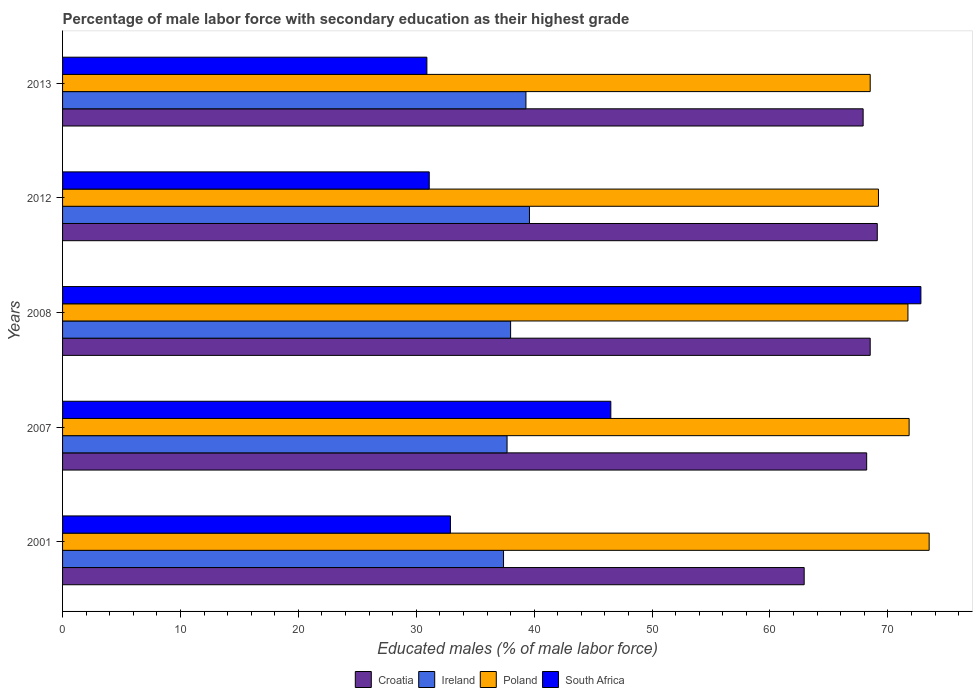How many bars are there on the 3rd tick from the top?
Offer a very short reply. 4. What is the label of the 5th group of bars from the top?
Ensure brevity in your answer.  2001. In how many cases, is the number of bars for a given year not equal to the number of legend labels?
Your answer should be very brief. 0. What is the percentage of male labor force with secondary education in Ireland in 2013?
Give a very brief answer. 39.3. Across all years, what is the maximum percentage of male labor force with secondary education in Poland?
Give a very brief answer. 73.5. Across all years, what is the minimum percentage of male labor force with secondary education in South Africa?
Make the answer very short. 30.9. In which year was the percentage of male labor force with secondary education in South Africa maximum?
Your response must be concise. 2008. In which year was the percentage of male labor force with secondary education in Poland minimum?
Ensure brevity in your answer.  2013. What is the total percentage of male labor force with secondary education in Ireland in the graph?
Ensure brevity in your answer.  192. What is the difference between the percentage of male labor force with secondary education in Croatia in 2007 and that in 2008?
Offer a terse response. -0.3. What is the difference between the percentage of male labor force with secondary education in Poland in 2008 and the percentage of male labor force with secondary education in South Africa in 2001?
Offer a very short reply. 38.8. What is the average percentage of male labor force with secondary education in South Africa per year?
Make the answer very short. 42.84. In the year 2013, what is the difference between the percentage of male labor force with secondary education in Poland and percentage of male labor force with secondary education in Croatia?
Offer a terse response. 0.6. In how many years, is the percentage of male labor force with secondary education in Croatia greater than 42 %?
Give a very brief answer. 5. What is the ratio of the percentage of male labor force with secondary education in Poland in 2001 to that in 2012?
Offer a terse response. 1.06. Is the difference between the percentage of male labor force with secondary education in Poland in 2001 and 2013 greater than the difference between the percentage of male labor force with secondary education in Croatia in 2001 and 2013?
Your response must be concise. Yes. What is the difference between the highest and the second highest percentage of male labor force with secondary education in South Africa?
Your answer should be very brief. 26.3. What is the difference between the highest and the lowest percentage of male labor force with secondary education in Ireland?
Make the answer very short. 2.2. In how many years, is the percentage of male labor force with secondary education in Croatia greater than the average percentage of male labor force with secondary education in Croatia taken over all years?
Your answer should be very brief. 4. Is the sum of the percentage of male labor force with secondary education in South Africa in 2012 and 2013 greater than the maximum percentage of male labor force with secondary education in Croatia across all years?
Your response must be concise. No. What does the 3rd bar from the top in 2001 represents?
Your answer should be very brief. Ireland. What does the 2nd bar from the bottom in 2012 represents?
Ensure brevity in your answer.  Ireland. How many bars are there?
Offer a very short reply. 20. Are all the bars in the graph horizontal?
Ensure brevity in your answer.  Yes. Are the values on the major ticks of X-axis written in scientific E-notation?
Provide a short and direct response. No. Where does the legend appear in the graph?
Your answer should be compact. Bottom center. What is the title of the graph?
Provide a succinct answer. Percentage of male labor force with secondary education as their highest grade. What is the label or title of the X-axis?
Your answer should be compact. Educated males (% of male labor force). What is the Educated males (% of male labor force) of Croatia in 2001?
Give a very brief answer. 62.9. What is the Educated males (% of male labor force) of Ireland in 2001?
Your response must be concise. 37.4. What is the Educated males (% of male labor force) of Poland in 2001?
Give a very brief answer. 73.5. What is the Educated males (% of male labor force) in South Africa in 2001?
Ensure brevity in your answer.  32.9. What is the Educated males (% of male labor force) in Croatia in 2007?
Keep it short and to the point. 68.2. What is the Educated males (% of male labor force) in Ireland in 2007?
Keep it short and to the point. 37.7. What is the Educated males (% of male labor force) of Poland in 2007?
Provide a succinct answer. 71.8. What is the Educated males (% of male labor force) in South Africa in 2007?
Give a very brief answer. 46.5. What is the Educated males (% of male labor force) of Croatia in 2008?
Offer a terse response. 68.5. What is the Educated males (% of male labor force) of Ireland in 2008?
Your response must be concise. 38. What is the Educated males (% of male labor force) of Poland in 2008?
Offer a terse response. 71.7. What is the Educated males (% of male labor force) of South Africa in 2008?
Ensure brevity in your answer.  72.8. What is the Educated males (% of male labor force) in Croatia in 2012?
Make the answer very short. 69.1. What is the Educated males (% of male labor force) of Ireland in 2012?
Provide a succinct answer. 39.6. What is the Educated males (% of male labor force) in Poland in 2012?
Your answer should be very brief. 69.2. What is the Educated males (% of male labor force) in South Africa in 2012?
Make the answer very short. 31.1. What is the Educated males (% of male labor force) of Croatia in 2013?
Provide a succinct answer. 67.9. What is the Educated males (% of male labor force) in Ireland in 2013?
Your answer should be very brief. 39.3. What is the Educated males (% of male labor force) in Poland in 2013?
Give a very brief answer. 68.5. What is the Educated males (% of male labor force) in South Africa in 2013?
Give a very brief answer. 30.9. Across all years, what is the maximum Educated males (% of male labor force) of Croatia?
Give a very brief answer. 69.1. Across all years, what is the maximum Educated males (% of male labor force) of Ireland?
Give a very brief answer. 39.6. Across all years, what is the maximum Educated males (% of male labor force) in Poland?
Provide a succinct answer. 73.5. Across all years, what is the maximum Educated males (% of male labor force) in South Africa?
Keep it short and to the point. 72.8. Across all years, what is the minimum Educated males (% of male labor force) of Croatia?
Provide a succinct answer. 62.9. Across all years, what is the minimum Educated males (% of male labor force) of Ireland?
Your answer should be very brief. 37.4. Across all years, what is the minimum Educated males (% of male labor force) in Poland?
Offer a very short reply. 68.5. Across all years, what is the minimum Educated males (% of male labor force) in South Africa?
Ensure brevity in your answer.  30.9. What is the total Educated males (% of male labor force) in Croatia in the graph?
Give a very brief answer. 336.6. What is the total Educated males (% of male labor force) of Ireland in the graph?
Your answer should be compact. 192. What is the total Educated males (% of male labor force) in Poland in the graph?
Your response must be concise. 354.7. What is the total Educated males (% of male labor force) in South Africa in the graph?
Give a very brief answer. 214.2. What is the difference between the Educated males (% of male labor force) of Ireland in 2001 and that in 2007?
Give a very brief answer. -0.3. What is the difference between the Educated males (% of male labor force) in Poland in 2001 and that in 2008?
Ensure brevity in your answer.  1.8. What is the difference between the Educated males (% of male labor force) of South Africa in 2001 and that in 2008?
Keep it short and to the point. -39.9. What is the difference between the Educated males (% of male labor force) of Poland in 2001 and that in 2012?
Offer a very short reply. 4.3. What is the difference between the Educated males (% of male labor force) of South Africa in 2001 and that in 2012?
Ensure brevity in your answer.  1.8. What is the difference between the Educated males (% of male labor force) in Croatia in 2001 and that in 2013?
Ensure brevity in your answer.  -5. What is the difference between the Educated males (% of male labor force) of Ireland in 2001 and that in 2013?
Offer a terse response. -1.9. What is the difference between the Educated males (% of male labor force) in Poland in 2001 and that in 2013?
Offer a terse response. 5. What is the difference between the Educated males (% of male labor force) in South Africa in 2001 and that in 2013?
Give a very brief answer. 2. What is the difference between the Educated males (% of male labor force) of Ireland in 2007 and that in 2008?
Offer a very short reply. -0.3. What is the difference between the Educated males (% of male labor force) in Poland in 2007 and that in 2008?
Give a very brief answer. 0.1. What is the difference between the Educated males (% of male labor force) of South Africa in 2007 and that in 2008?
Your response must be concise. -26.3. What is the difference between the Educated males (% of male labor force) of Croatia in 2007 and that in 2012?
Make the answer very short. -0.9. What is the difference between the Educated males (% of male labor force) of Poland in 2007 and that in 2012?
Ensure brevity in your answer.  2.6. What is the difference between the Educated males (% of male labor force) of South Africa in 2007 and that in 2012?
Offer a very short reply. 15.4. What is the difference between the Educated males (% of male labor force) of Croatia in 2007 and that in 2013?
Provide a succinct answer. 0.3. What is the difference between the Educated males (% of male labor force) of Poland in 2007 and that in 2013?
Your answer should be compact. 3.3. What is the difference between the Educated males (% of male labor force) of Croatia in 2008 and that in 2012?
Ensure brevity in your answer.  -0.6. What is the difference between the Educated males (% of male labor force) in Poland in 2008 and that in 2012?
Ensure brevity in your answer.  2.5. What is the difference between the Educated males (% of male labor force) of South Africa in 2008 and that in 2012?
Offer a very short reply. 41.7. What is the difference between the Educated males (% of male labor force) of South Africa in 2008 and that in 2013?
Your response must be concise. 41.9. What is the difference between the Educated males (% of male labor force) of Croatia in 2001 and the Educated males (% of male labor force) of Ireland in 2007?
Your answer should be very brief. 25.2. What is the difference between the Educated males (% of male labor force) in Croatia in 2001 and the Educated males (% of male labor force) in Poland in 2007?
Your response must be concise. -8.9. What is the difference between the Educated males (% of male labor force) of Ireland in 2001 and the Educated males (% of male labor force) of Poland in 2007?
Ensure brevity in your answer.  -34.4. What is the difference between the Educated males (% of male labor force) in Ireland in 2001 and the Educated males (% of male labor force) in South Africa in 2007?
Keep it short and to the point. -9.1. What is the difference between the Educated males (% of male labor force) in Croatia in 2001 and the Educated males (% of male labor force) in Ireland in 2008?
Your answer should be very brief. 24.9. What is the difference between the Educated males (% of male labor force) of Croatia in 2001 and the Educated males (% of male labor force) of Poland in 2008?
Provide a succinct answer. -8.8. What is the difference between the Educated males (% of male labor force) in Ireland in 2001 and the Educated males (% of male labor force) in Poland in 2008?
Offer a very short reply. -34.3. What is the difference between the Educated males (% of male labor force) in Ireland in 2001 and the Educated males (% of male labor force) in South Africa in 2008?
Offer a very short reply. -35.4. What is the difference between the Educated males (% of male labor force) of Poland in 2001 and the Educated males (% of male labor force) of South Africa in 2008?
Make the answer very short. 0.7. What is the difference between the Educated males (% of male labor force) of Croatia in 2001 and the Educated males (% of male labor force) of Ireland in 2012?
Offer a very short reply. 23.3. What is the difference between the Educated males (% of male labor force) of Croatia in 2001 and the Educated males (% of male labor force) of South Africa in 2012?
Provide a succinct answer. 31.8. What is the difference between the Educated males (% of male labor force) of Ireland in 2001 and the Educated males (% of male labor force) of Poland in 2012?
Ensure brevity in your answer.  -31.8. What is the difference between the Educated males (% of male labor force) of Ireland in 2001 and the Educated males (% of male labor force) of South Africa in 2012?
Provide a succinct answer. 6.3. What is the difference between the Educated males (% of male labor force) of Poland in 2001 and the Educated males (% of male labor force) of South Africa in 2012?
Offer a terse response. 42.4. What is the difference between the Educated males (% of male labor force) in Croatia in 2001 and the Educated males (% of male labor force) in Ireland in 2013?
Your answer should be compact. 23.6. What is the difference between the Educated males (% of male labor force) of Ireland in 2001 and the Educated males (% of male labor force) of Poland in 2013?
Your response must be concise. -31.1. What is the difference between the Educated males (% of male labor force) in Ireland in 2001 and the Educated males (% of male labor force) in South Africa in 2013?
Keep it short and to the point. 6.5. What is the difference between the Educated males (% of male labor force) in Poland in 2001 and the Educated males (% of male labor force) in South Africa in 2013?
Your answer should be compact. 42.6. What is the difference between the Educated males (% of male labor force) in Croatia in 2007 and the Educated males (% of male labor force) in Ireland in 2008?
Your answer should be very brief. 30.2. What is the difference between the Educated males (% of male labor force) in Croatia in 2007 and the Educated males (% of male labor force) in Poland in 2008?
Offer a very short reply. -3.5. What is the difference between the Educated males (% of male labor force) in Ireland in 2007 and the Educated males (% of male labor force) in Poland in 2008?
Ensure brevity in your answer.  -34. What is the difference between the Educated males (% of male labor force) in Ireland in 2007 and the Educated males (% of male labor force) in South Africa in 2008?
Make the answer very short. -35.1. What is the difference between the Educated males (% of male labor force) in Poland in 2007 and the Educated males (% of male labor force) in South Africa in 2008?
Keep it short and to the point. -1. What is the difference between the Educated males (% of male labor force) in Croatia in 2007 and the Educated males (% of male labor force) in Ireland in 2012?
Your answer should be very brief. 28.6. What is the difference between the Educated males (% of male labor force) in Croatia in 2007 and the Educated males (% of male labor force) in Poland in 2012?
Make the answer very short. -1. What is the difference between the Educated males (% of male labor force) of Croatia in 2007 and the Educated males (% of male labor force) of South Africa in 2012?
Your answer should be very brief. 37.1. What is the difference between the Educated males (% of male labor force) of Ireland in 2007 and the Educated males (% of male labor force) of Poland in 2012?
Provide a short and direct response. -31.5. What is the difference between the Educated males (% of male labor force) of Ireland in 2007 and the Educated males (% of male labor force) of South Africa in 2012?
Your answer should be very brief. 6.6. What is the difference between the Educated males (% of male labor force) in Poland in 2007 and the Educated males (% of male labor force) in South Africa in 2012?
Your answer should be compact. 40.7. What is the difference between the Educated males (% of male labor force) of Croatia in 2007 and the Educated males (% of male labor force) of Ireland in 2013?
Offer a terse response. 28.9. What is the difference between the Educated males (% of male labor force) of Croatia in 2007 and the Educated males (% of male labor force) of South Africa in 2013?
Give a very brief answer. 37.3. What is the difference between the Educated males (% of male labor force) of Ireland in 2007 and the Educated males (% of male labor force) of Poland in 2013?
Make the answer very short. -30.8. What is the difference between the Educated males (% of male labor force) in Poland in 2007 and the Educated males (% of male labor force) in South Africa in 2013?
Offer a terse response. 40.9. What is the difference between the Educated males (% of male labor force) of Croatia in 2008 and the Educated males (% of male labor force) of Ireland in 2012?
Your answer should be very brief. 28.9. What is the difference between the Educated males (% of male labor force) of Croatia in 2008 and the Educated males (% of male labor force) of Poland in 2012?
Make the answer very short. -0.7. What is the difference between the Educated males (% of male labor force) of Croatia in 2008 and the Educated males (% of male labor force) of South Africa in 2012?
Make the answer very short. 37.4. What is the difference between the Educated males (% of male labor force) in Ireland in 2008 and the Educated males (% of male labor force) in Poland in 2012?
Provide a succinct answer. -31.2. What is the difference between the Educated males (% of male labor force) in Poland in 2008 and the Educated males (% of male labor force) in South Africa in 2012?
Make the answer very short. 40.6. What is the difference between the Educated males (% of male labor force) of Croatia in 2008 and the Educated males (% of male labor force) of Ireland in 2013?
Your answer should be compact. 29.2. What is the difference between the Educated males (% of male labor force) in Croatia in 2008 and the Educated males (% of male labor force) in South Africa in 2013?
Offer a very short reply. 37.6. What is the difference between the Educated males (% of male labor force) in Ireland in 2008 and the Educated males (% of male labor force) in Poland in 2013?
Provide a succinct answer. -30.5. What is the difference between the Educated males (% of male labor force) of Ireland in 2008 and the Educated males (% of male labor force) of South Africa in 2013?
Ensure brevity in your answer.  7.1. What is the difference between the Educated males (% of male labor force) of Poland in 2008 and the Educated males (% of male labor force) of South Africa in 2013?
Your answer should be very brief. 40.8. What is the difference between the Educated males (% of male labor force) in Croatia in 2012 and the Educated males (% of male labor force) in Ireland in 2013?
Give a very brief answer. 29.8. What is the difference between the Educated males (% of male labor force) of Croatia in 2012 and the Educated males (% of male labor force) of Poland in 2013?
Provide a succinct answer. 0.6. What is the difference between the Educated males (% of male labor force) of Croatia in 2012 and the Educated males (% of male labor force) of South Africa in 2013?
Make the answer very short. 38.2. What is the difference between the Educated males (% of male labor force) of Ireland in 2012 and the Educated males (% of male labor force) of Poland in 2013?
Provide a succinct answer. -28.9. What is the difference between the Educated males (% of male labor force) in Poland in 2012 and the Educated males (% of male labor force) in South Africa in 2013?
Provide a succinct answer. 38.3. What is the average Educated males (% of male labor force) in Croatia per year?
Provide a short and direct response. 67.32. What is the average Educated males (% of male labor force) of Ireland per year?
Ensure brevity in your answer.  38.4. What is the average Educated males (% of male labor force) in Poland per year?
Keep it short and to the point. 70.94. What is the average Educated males (% of male labor force) in South Africa per year?
Give a very brief answer. 42.84. In the year 2001, what is the difference between the Educated males (% of male labor force) of Ireland and Educated males (% of male labor force) of Poland?
Give a very brief answer. -36.1. In the year 2001, what is the difference between the Educated males (% of male labor force) of Poland and Educated males (% of male labor force) of South Africa?
Ensure brevity in your answer.  40.6. In the year 2007, what is the difference between the Educated males (% of male labor force) of Croatia and Educated males (% of male labor force) of Ireland?
Offer a terse response. 30.5. In the year 2007, what is the difference between the Educated males (% of male labor force) in Croatia and Educated males (% of male labor force) in Poland?
Your answer should be compact. -3.6. In the year 2007, what is the difference between the Educated males (% of male labor force) of Croatia and Educated males (% of male labor force) of South Africa?
Your answer should be very brief. 21.7. In the year 2007, what is the difference between the Educated males (% of male labor force) of Ireland and Educated males (% of male labor force) of Poland?
Give a very brief answer. -34.1. In the year 2007, what is the difference between the Educated males (% of male labor force) in Ireland and Educated males (% of male labor force) in South Africa?
Make the answer very short. -8.8. In the year 2007, what is the difference between the Educated males (% of male labor force) of Poland and Educated males (% of male labor force) of South Africa?
Your response must be concise. 25.3. In the year 2008, what is the difference between the Educated males (% of male labor force) of Croatia and Educated males (% of male labor force) of Ireland?
Provide a short and direct response. 30.5. In the year 2008, what is the difference between the Educated males (% of male labor force) in Croatia and Educated males (% of male labor force) in South Africa?
Provide a short and direct response. -4.3. In the year 2008, what is the difference between the Educated males (% of male labor force) of Ireland and Educated males (% of male labor force) of Poland?
Offer a terse response. -33.7. In the year 2008, what is the difference between the Educated males (% of male labor force) of Ireland and Educated males (% of male labor force) of South Africa?
Offer a very short reply. -34.8. In the year 2008, what is the difference between the Educated males (% of male labor force) in Poland and Educated males (% of male labor force) in South Africa?
Ensure brevity in your answer.  -1.1. In the year 2012, what is the difference between the Educated males (% of male labor force) in Croatia and Educated males (% of male labor force) in Ireland?
Provide a succinct answer. 29.5. In the year 2012, what is the difference between the Educated males (% of male labor force) of Croatia and Educated males (% of male labor force) of Poland?
Give a very brief answer. -0.1. In the year 2012, what is the difference between the Educated males (% of male labor force) of Croatia and Educated males (% of male labor force) of South Africa?
Give a very brief answer. 38. In the year 2012, what is the difference between the Educated males (% of male labor force) of Ireland and Educated males (% of male labor force) of Poland?
Your answer should be very brief. -29.6. In the year 2012, what is the difference between the Educated males (% of male labor force) of Ireland and Educated males (% of male labor force) of South Africa?
Your answer should be compact. 8.5. In the year 2012, what is the difference between the Educated males (% of male labor force) of Poland and Educated males (% of male labor force) of South Africa?
Your answer should be very brief. 38.1. In the year 2013, what is the difference between the Educated males (% of male labor force) in Croatia and Educated males (% of male labor force) in Ireland?
Your response must be concise. 28.6. In the year 2013, what is the difference between the Educated males (% of male labor force) in Croatia and Educated males (% of male labor force) in South Africa?
Keep it short and to the point. 37. In the year 2013, what is the difference between the Educated males (% of male labor force) in Ireland and Educated males (% of male labor force) in Poland?
Make the answer very short. -29.2. In the year 2013, what is the difference between the Educated males (% of male labor force) of Ireland and Educated males (% of male labor force) of South Africa?
Provide a succinct answer. 8.4. In the year 2013, what is the difference between the Educated males (% of male labor force) of Poland and Educated males (% of male labor force) of South Africa?
Your answer should be very brief. 37.6. What is the ratio of the Educated males (% of male labor force) in Croatia in 2001 to that in 2007?
Provide a short and direct response. 0.92. What is the ratio of the Educated males (% of male labor force) in Ireland in 2001 to that in 2007?
Your answer should be very brief. 0.99. What is the ratio of the Educated males (% of male labor force) of Poland in 2001 to that in 2007?
Offer a very short reply. 1.02. What is the ratio of the Educated males (% of male labor force) in South Africa in 2001 to that in 2007?
Offer a very short reply. 0.71. What is the ratio of the Educated males (% of male labor force) in Croatia in 2001 to that in 2008?
Keep it short and to the point. 0.92. What is the ratio of the Educated males (% of male labor force) in Ireland in 2001 to that in 2008?
Give a very brief answer. 0.98. What is the ratio of the Educated males (% of male labor force) in Poland in 2001 to that in 2008?
Offer a terse response. 1.03. What is the ratio of the Educated males (% of male labor force) in South Africa in 2001 to that in 2008?
Your answer should be compact. 0.45. What is the ratio of the Educated males (% of male labor force) of Croatia in 2001 to that in 2012?
Your answer should be very brief. 0.91. What is the ratio of the Educated males (% of male labor force) in Ireland in 2001 to that in 2012?
Give a very brief answer. 0.94. What is the ratio of the Educated males (% of male labor force) of Poland in 2001 to that in 2012?
Offer a terse response. 1.06. What is the ratio of the Educated males (% of male labor force) in South Africa in 2001 to that in 2012?
Make the answer very short. 1.06. What is the ratio of the Educated males (% of male labor force) of Croatia in 2001 to that in 2013?
Make the answer very short. 0.93. What is the ratio of the Educated males (% of male labor force) in Ireland in 2001 to that in 2013?
Your response must be concise. 0.95. What is the ratio of the Educated males (% of male labor force) in Poland in 2001 to that in 2013?
Your response must be concise. 1.07. What is the ratio of the Educated males (% of male labor force) of South Africa in 2001 to that in 2013?
Ensure brevity in your answer.  1.06. What is the ratio of the Educated males (% of male labor force) in Croatia in 2007 to that in 2008?
Provide a short and direct response. 1. What is the ratio of the Educated males (% of male labor force) in Ireland in 2007 to that in 2008?
Your answer should be very brief. 0.99. What is the ratio of the Educated males (% of male labor force) in Poland in 2007 to that in 2008?
Make the answer very short. 1. What is the ratio of the Educated males (% of male labor force) in South Africa in 2007 to that in 2008?
Offer a terse response. 0.64. What is the ratio of the Educated males (% of male labor force) in Croatia in 2007 to that in 2012?
Provide a succinct answer. 0.99. What is the ratio of the Educated males (% of male labor force) of Poland in 2007 to that in 2012?
Ensure brevity in your answer.  1.04. What is the ratio of the Educated males (% of male labor force) of South Africa in 2007 to that in 2012?
Make the answer very short. 1.5. What is the ratio of the Educated males (% of male labor force) of Croatia in 2007 to that in 2013?
Your response must be concise. 1. What is the ratio of the Educated males (% of male labor force) in Ireland in 2007 to that in 2013?
Keep it short and to the point. 0.96. What is the ratio of the Educated males (% of male labor force) of Poland in 2007 to that in 2013?
Provide a short and direct response. 1.05. What is the ratio of the Educated males (% of male labor force) in South Africa in 2007 to that in 2013?
Provide a short and direct response. 1.5. What is the ratio of the Educated males (% of male labor force) in Croatia in 2008 to that in 2012?
Give a very brief answer. 0.99. What is the ratio of the Educated males (% of male labor force) of Ireland in 2008 to that in 2012?
Ensure brevity in your answer.  0.96. What is the ratio of the Educated males (% of male labor force) in Poland in 2008 to that in 2012?
Give a very brief answer. 1.04. What is the ratio of the Educated males (% of male labor force) of South Africa in 2008 to that in 2012?
Make the answer very short. 2.34. What is the ratio of the Educated males (% of male labor force) of Croatia in 2008 to that in 2013?
Ensure brevity in your answer.  1.01. What is the ratio of the Educated males (% of male labor force) of Ireland in 2008 to that in 2013?
Give a very brief answer. 0.97. What is the ratio of the Educated males (% of male labor force) of Poland in 2008 to that in 2013?
Provide a short and direct response. 1.05. What is the ratio of the Educated males (% of male labor force) in South Africa in 2008 to that in 2013?
Keep it short and to the point. 2.36. What is the ratio of the Educated males (% of male labor force) in Croatia in 2012 to that in 2013?
Give a very brief answer. 1.02. What is the ratio of the Educated males (% of male labor force) in Ireland in 2012 to that in 2013?
Ensure brevity in your answer.  1.01. What is the ratio of the Educated males (% of male labor force) of Poland in 2012 to that in 2013?
Offer a terse response. 1.01. What is the difference between the highest and the second highest Educated males (% of male labor force) of Ireland?
Offer a very short reply. 0.3. What is the difference between the highest and the second highest Educated males (% of male labor force) of South Africa?
Your response must be concise. 26.3. What is the difference between the highest and the lowest Educated males (% of male labor force) in Croatia?
Ensure brevity in your answer.  6.2. What is the difference between the highest and the lowest Educated males (% of male labor force) of Poland?
Provide a succinct answer. 5. What is the difference between the highest and the lowest Educated males (% of male labor force) in South Africa?
Offer a terse response. 41.9. 